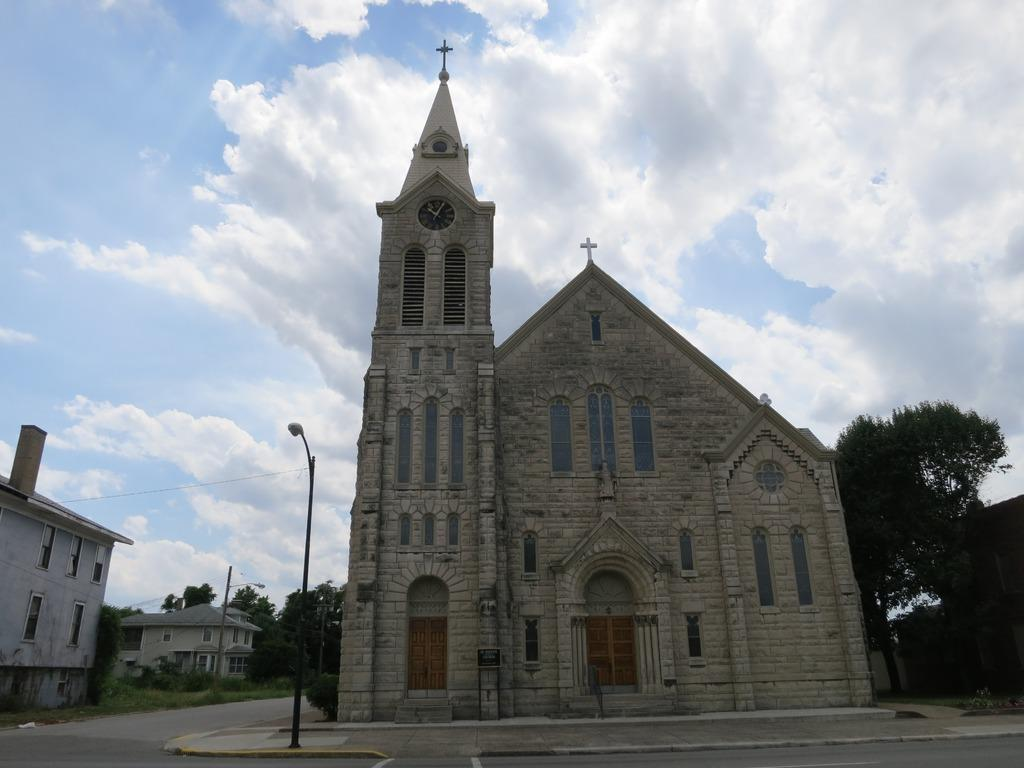What type of structures can be seen in the image? There are buildings in the image. What other natural elements are present in the image? There are trees in the image. What type of lighting is present in the image? There is a pole light in the image. How would you describe the sky in the image? The sky is blue and cloudy in the image. Can you tell me how many times the person in the image kicks the vessel? There is no person or vessel present in the image; it only features buildings, trees, a pole light, and the sky. 